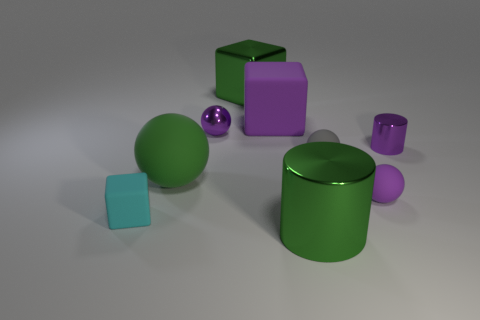Subtract all green spheres. How many spheres are left? 3 Subtract all tiny purple metallic spheres. How many spheres are left? 3 Subtract all yellow balls. Subtract all purple cylinders. How many balls are left? 4 Add 1 tiny purple rubber things. How many objects exist? 10 Subtract all cubes. How many objects are left? 6 Subtract 1 green cubes. How many objects are left? 8 Subtract all small cylinders. Subtract all small gray rubber objects. How many objects are left? 7 Add 9 shiny blocks. How many shiny blocks are left? 10 Add 8 large matte objects. How many large matte objects exist? 10 